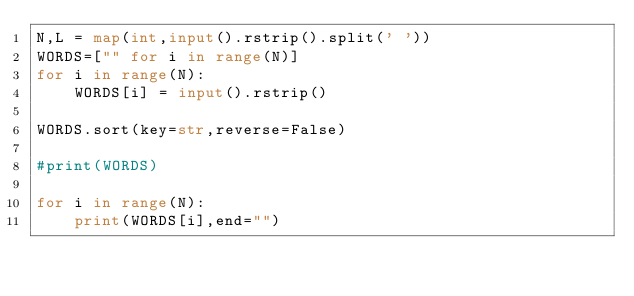Convert code to text. <code><loc_0><loc_0><loc_500><loc_500><_Python_>N,L = map(int,input().rstrip().split(' '))
WORDS=["" for i in range(N)]
for i in range(N):
    WORDS[i] = input().rstrip()

WORDS.sort(key=str,reverse=False)

#print(WORDS)

for i in range(N):
    print(WORDS[i],end="")</code> 